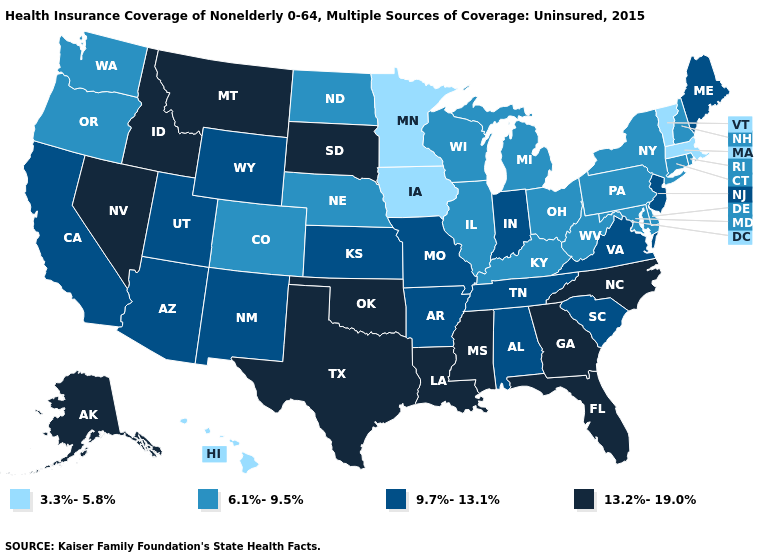How many symbols are there in the legend?
Keep it brief. 4. What is the value of Tennessee?
Quick response, please. 9.7%-13.1%. What is the value of New Jersey?
Concise answer only. 9.7%-13.1%. Which states have the lowest value in the USA?
Give a very brief answer. Hawaii, Iowa, Massachusetts, Minnesota, Vermont. Does Hawaii have the lowest value in the USA?
Keep it brief. Yes. What is the value of Pennsylvania?
Answer briefly. 6.1%-9.5%. Does Louisiana have the lowest value in the USA?
Concise answer only. No. Among the states that border New Mexico , which have the highest value?
Quick response, please. Oklahoma, Texas. Name the states that have a value in the range 13.2%-19.0%?
Quick response, please. Alaska, Florida, Georgia, Idaho, Louisiana, Mississippi, Montana, Nevada, North Carolina, Oklahoma, South Dakota, Texas. Does the map have missing data?
Give a very brief answer. No. What is the value of New Mexico?
Concise answer only. 9.7%-13.1%. Does Georgia have the lowest value in the USA?
Keep it brief. No. What is the value of Pennsylvania?
Be succinct. 6.1%-9.5%. What is the highest value in states that border South Dakota?
Give a very brief answer. 13.2%-19.0%. Name the states that have a value in the range 3.3%-5.8%?
Short answer required. Hawaii, Iowa, Massachusetts, Minnesota, Vermont. 